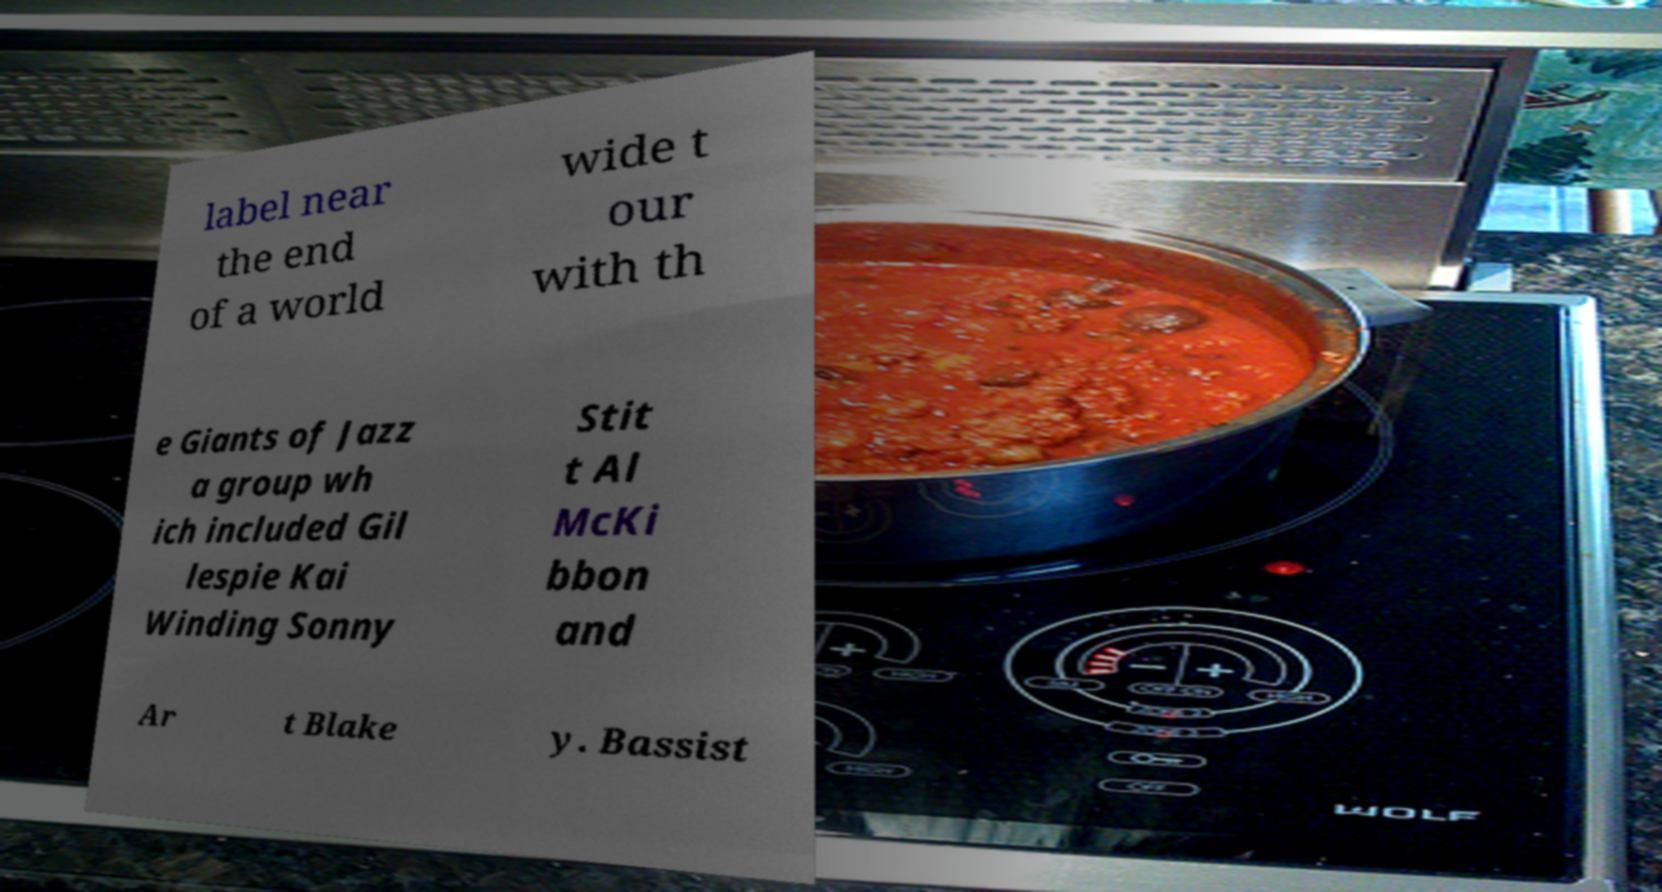I need the written content from this picture converted into text. Can you do that? label near the end of a world wide t our with th e Giants of Jazz a group wh ich included Gil lespie Kai Winding Sonny Stit t Al McKi bbon and Ar t Blake y. Bassist 